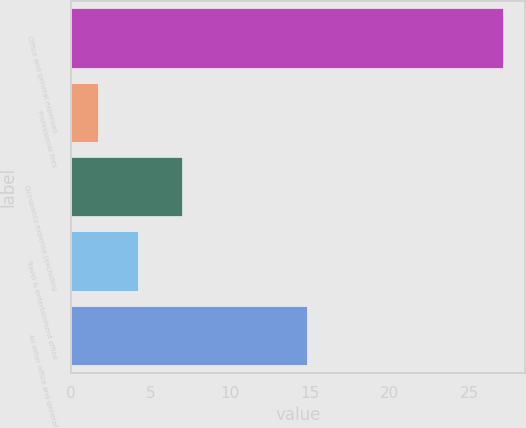<chart> <loc_0><loc_0><loc_500><loc_500><bar_chart><fcel>Office and general expenses<fcel>Professional fees<fcel>Occupancy expense (excluding<fcel>Travel & entertainment office<fcel>All other office and general<nl><fcel>27.1<fcel>1.7<fcel>7<fcel>4.24<fcel>14.8<nl></chart> 